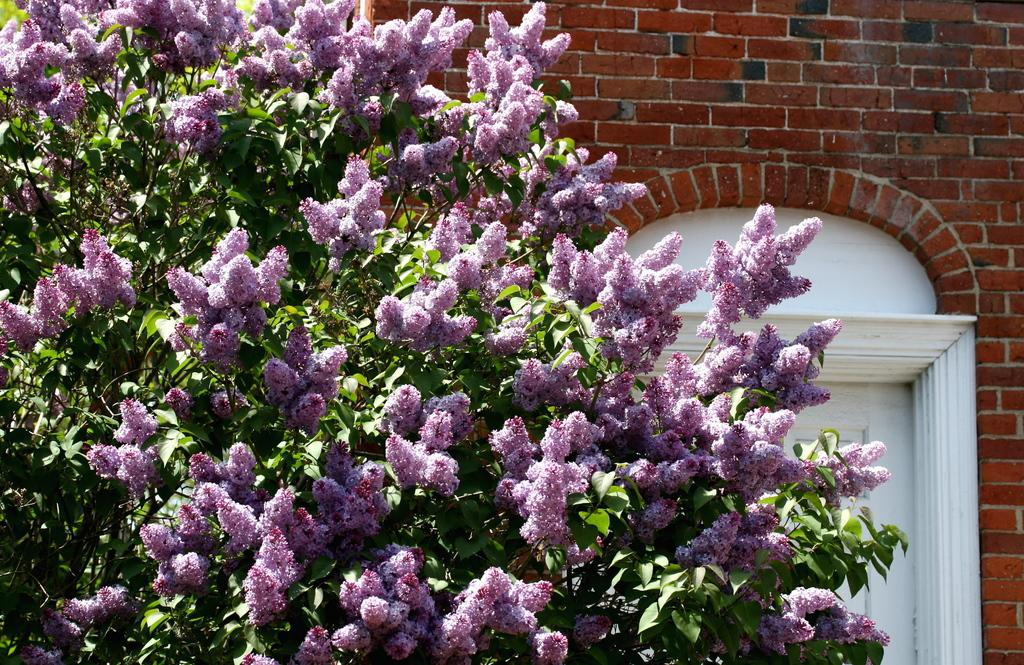What type of plant is present in the image? There is a tree in the image. What is special about the tree in the image? The tree has flowers on it. What type of structure is visible in the image? There is a brick wall in the image. Is there any entrance or exit on the brick wall? Yes, there is a door on the brick wall. What color is the ink used to write on the tree in the image? There is no ink or writing present on the tree in the image. What type of animal can be seen playing with the kitten in the image? There is no kitten or any other animal present in the image. 